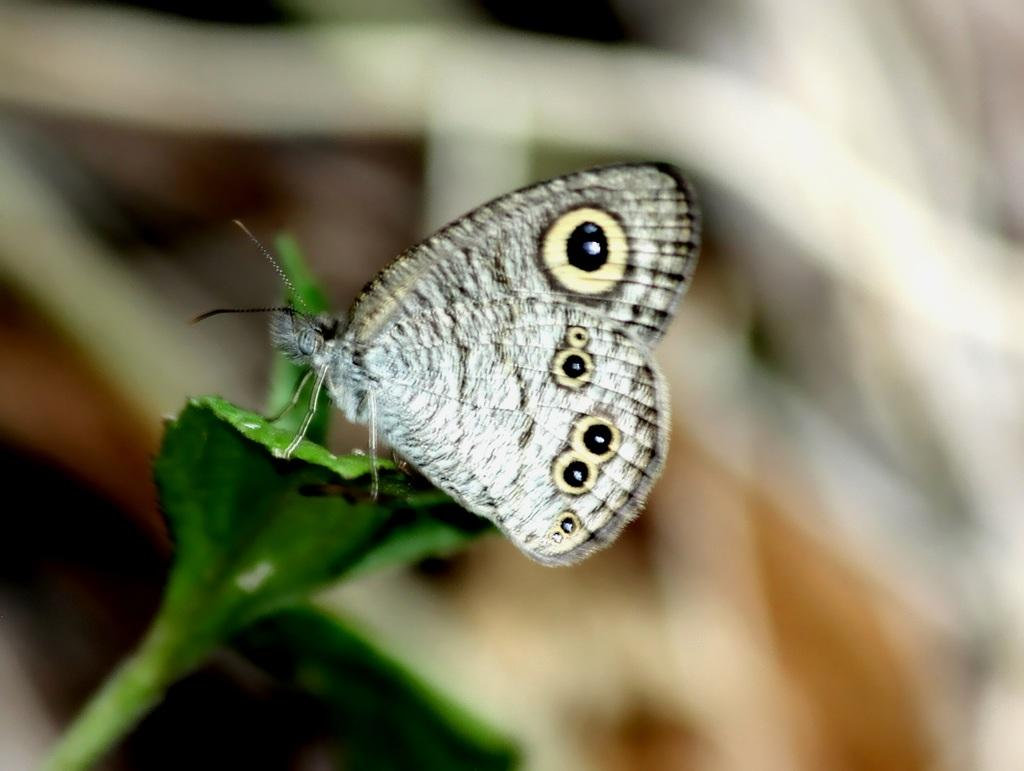What is the main subject of the image? There is a butterfly in the image. Where is the butterfly located? The butterfly is on a leaf. What color is the background of the image? The background of the image is white. What type of net can be seen in the image? There is no net present in the image; it features a butterfly on a leaf with a white background. 